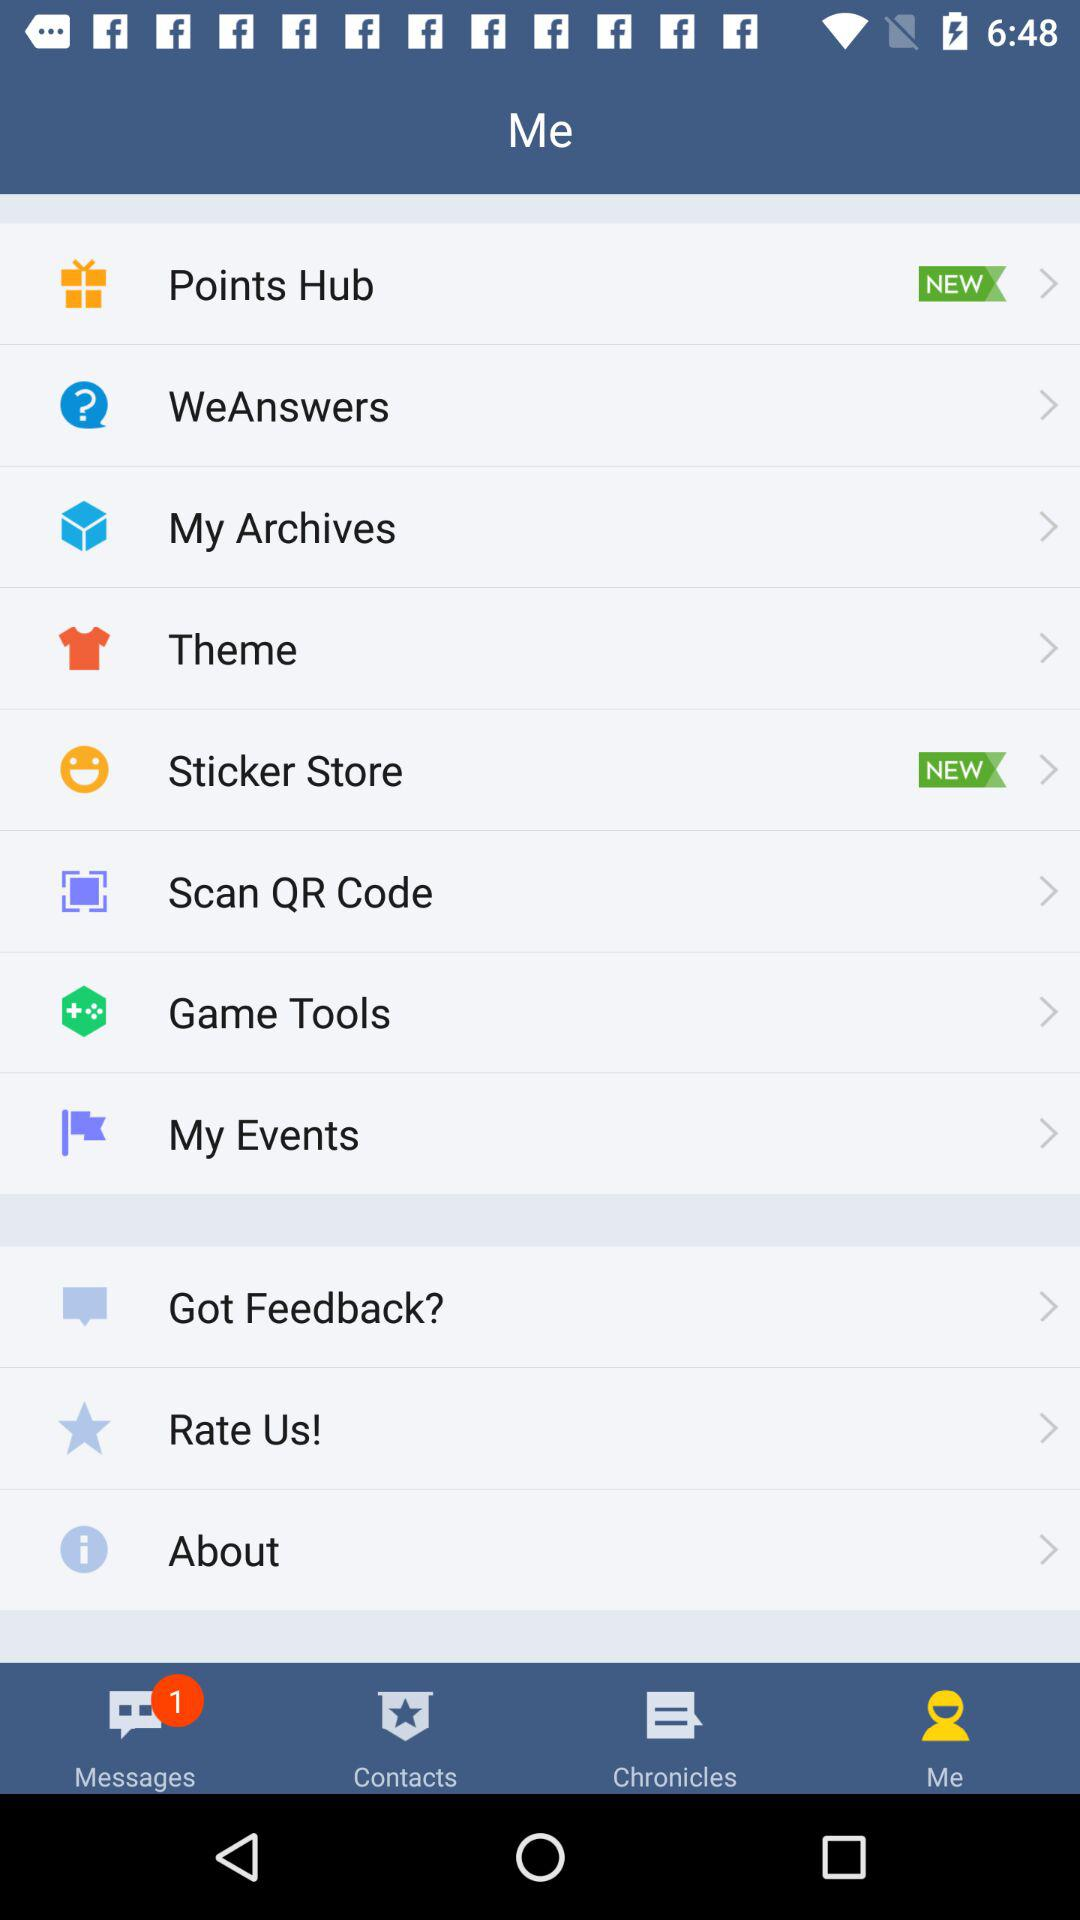What is the selected tab? The selected tab is "Me". 